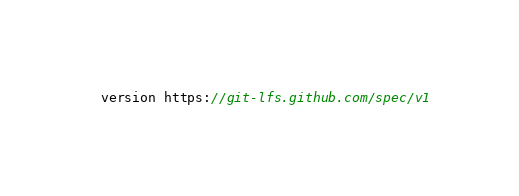<code> <loc_0><loc_0><loc_500><loc_500><_JavaScript_>version https://git-lfs.github.com/spec/v1</code> 